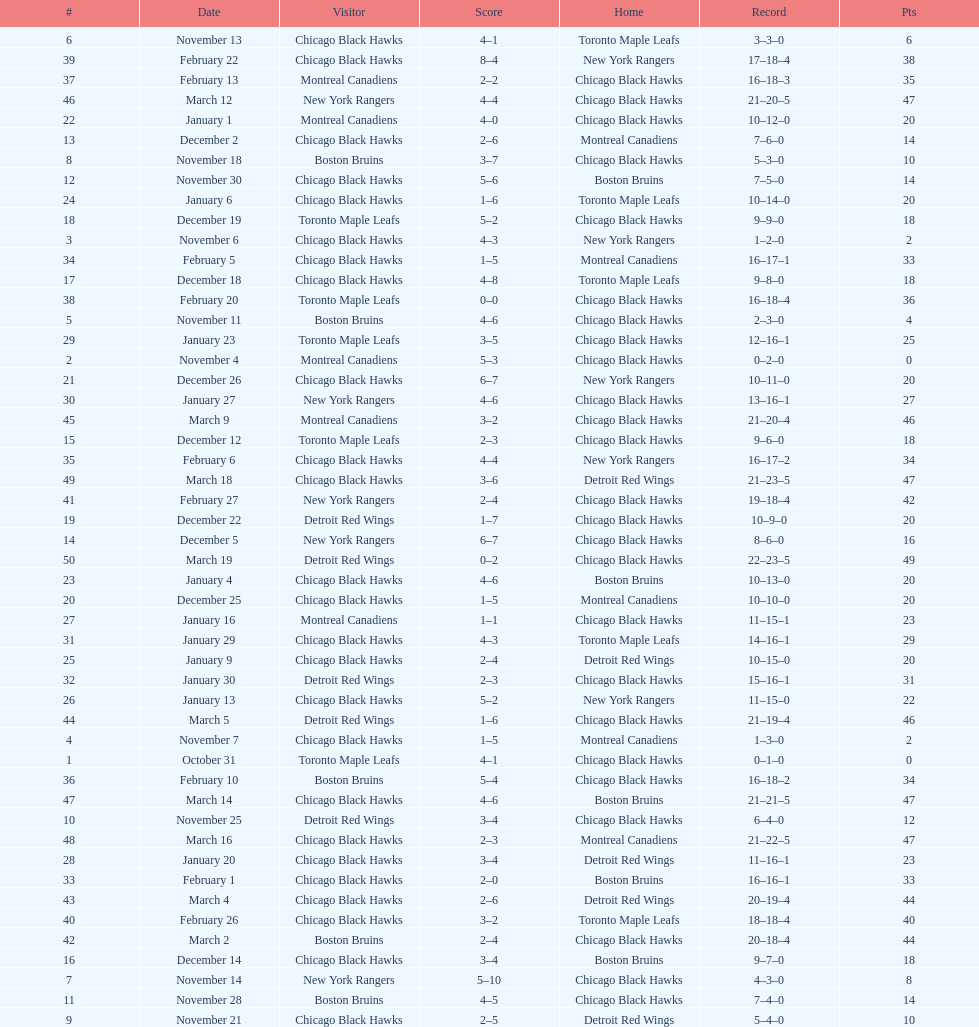What was the total amount of points scored on november 4th? 8. 